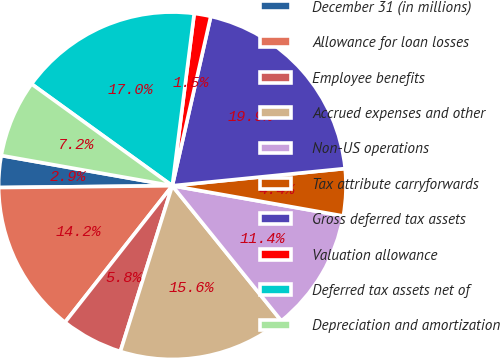<chart> <loc_0><loc_0><loc_500><loc_500><pie_chart><fcel>December 31 (in millions)<fcel>Allowance for loan losses<fcel>Employee benefits<fcel>Accrued expenses and other<fcel>Non-US operations<fcel>Tax attribute carryforwards<fcel>Gross deferred tax assets<fcel>Valuation allowance<fcel>Deferred tax assets net of<fcel>Depreciation and amortization<nl><fcel>2.95%<fcel>14.23%<fcel>5.77%<fcel>15.64%<fcel>11.41%<fcel>4.36%<fcel>19.87%<fcel>1.54%<fcel>17.05%<fcel>7.18%<nl></chart> 